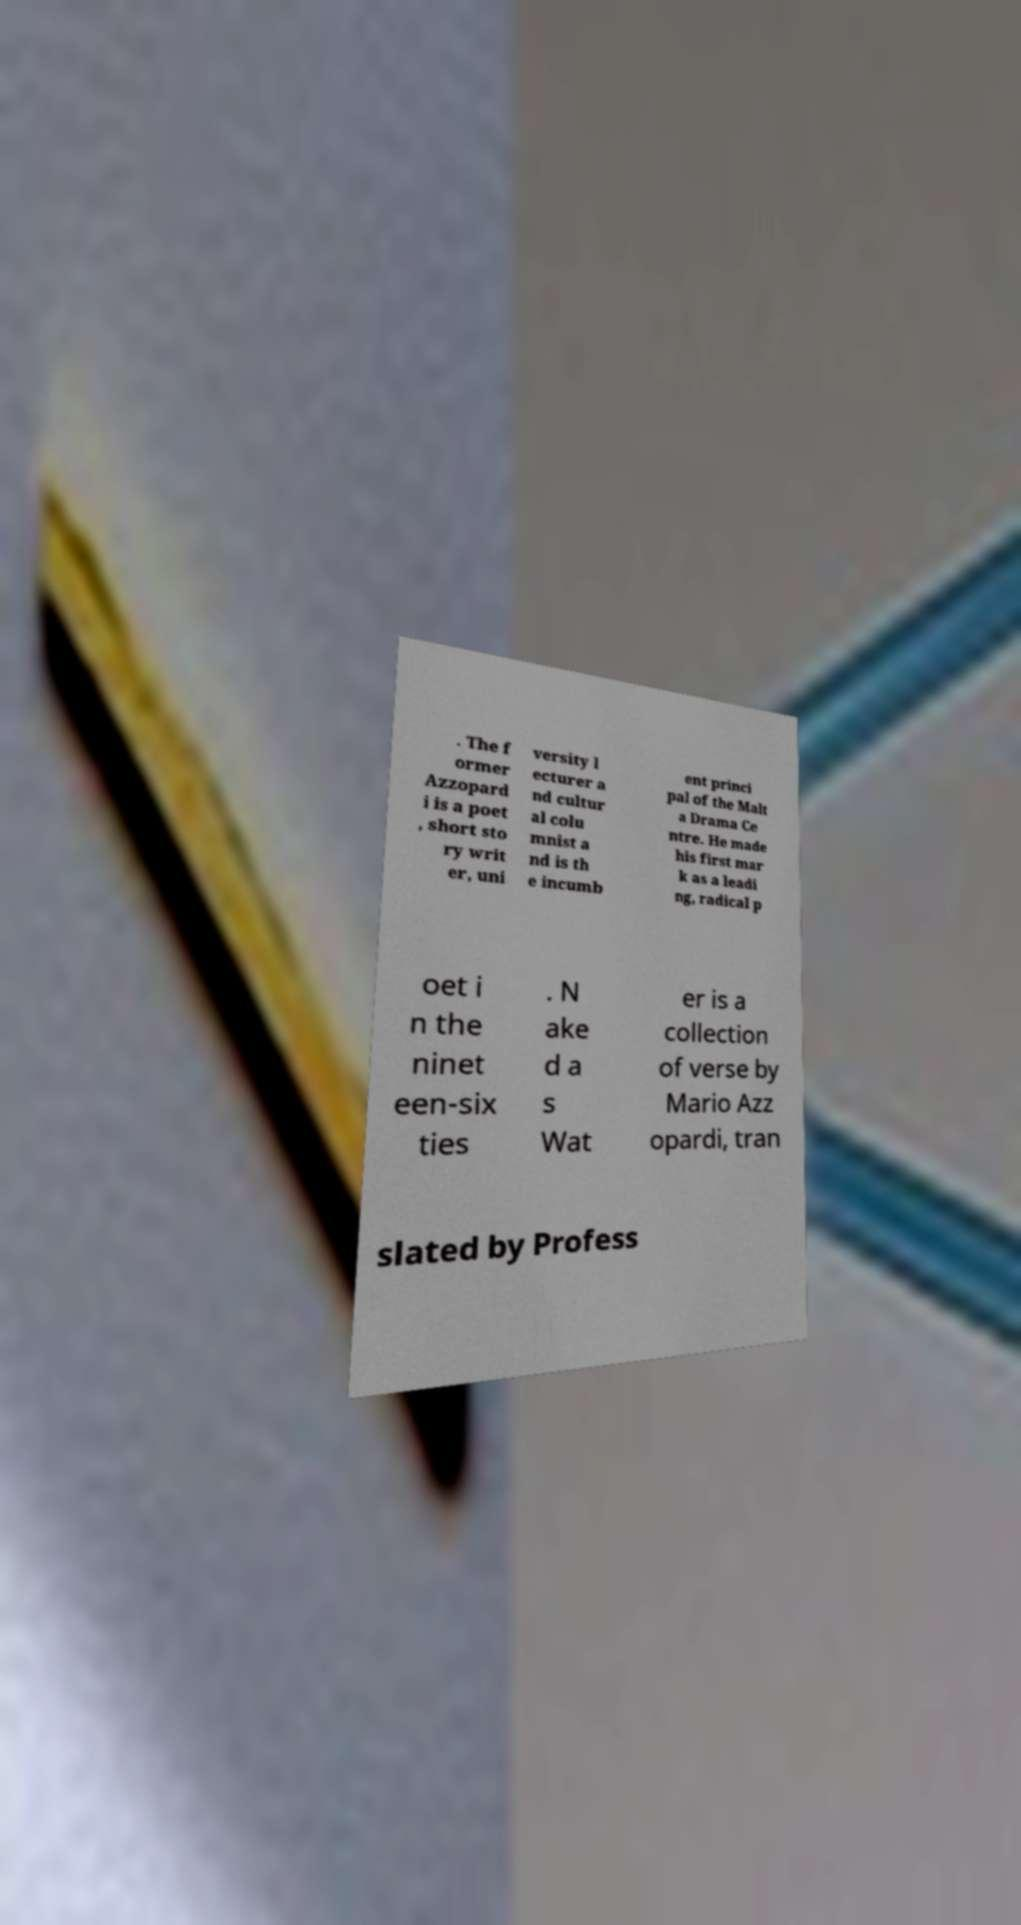Please identify and transcribe the text found in this image. . The f ormer Azzopard i is a poet , short sto ry writ er, uni versity l ecturer a nd cultur al colu mnist a nd is th e incumb ent princi pal of the Malt a Drama Ce ntre. He made his first mar k as a leadi ng, radical p oet i n the ninet een-six ties . N ake d a s Wat er is a collection of verse by Mario Azz opardi, tran slated by Profess 